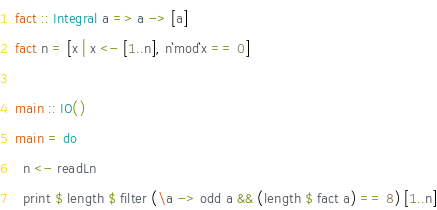<code> <loc_0><loc_0><loc_500><loc_500><_Haskell_>fact :: Integral a => a -> [a]
fact n = [x | x <- [1..n], n`mod`x == 0]

main :: IO()
main = do
  n <- readLn
  print $ length $ filter (\a -> odd a && (length $ fact a) == 8) [1..n]
</code> 